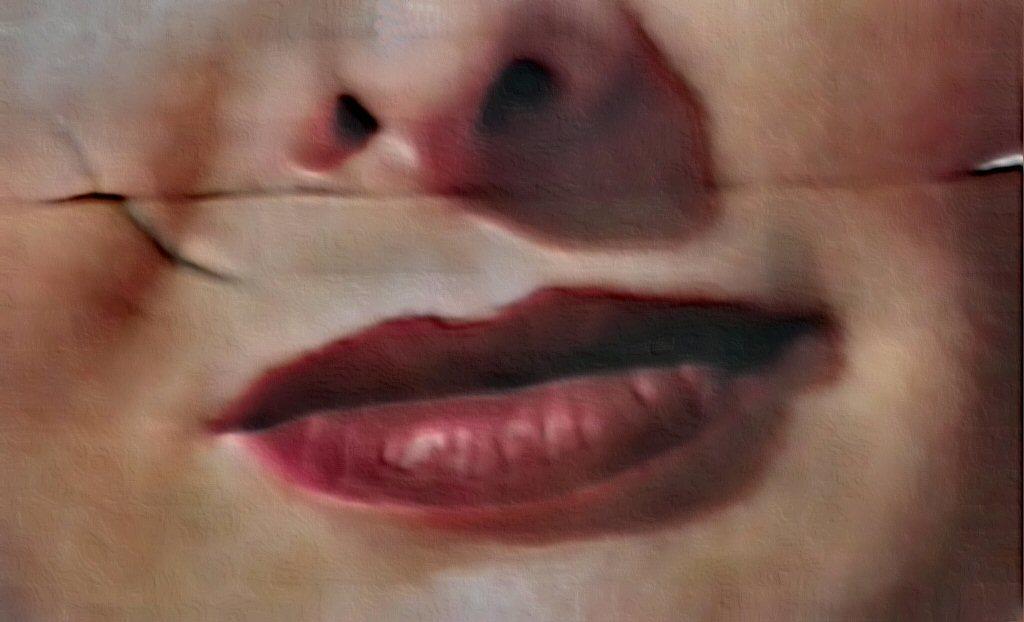Could you give a brief overview of what you see in this image? In this picture I can observe nose and lips of a human face. This picture is partially blurred. 